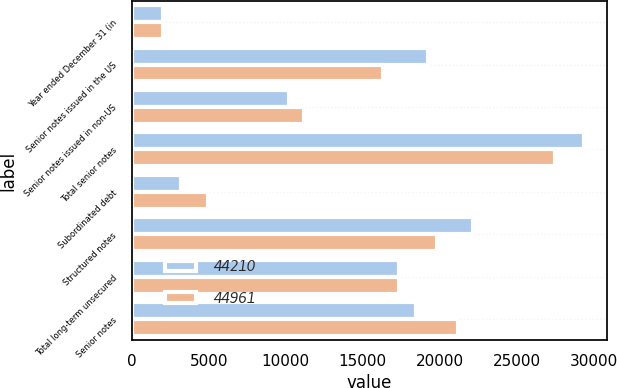<chart> <loc_0><loc_0><loc_500><loc_500><stacked_bar_chart><ecel><fcel>Year ended December 31 (in<fcel>Senior notes issued in the US<fcel>Senior notes issued in non-US<fcel>Total senior notes<fcel>Subordinated debt<fcel>Structured notes<fcel>Total long-term unsecured<fcel>Senior notes<nl><fcel>44210<fcel>2015<fcel>19212<fcel>10188<fcel>29400<fcel>3210<fcel>22165<fcel>17388<fcel>18454<nl><fcel>44961<fcel>2014<fcel>16322<fcel>11193<fcel>27515<fcel>4956<fcel>19806<fcel>17388<fcel>21169<nl></chart> 